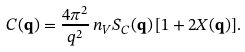<formula> <loc_0><loc_0><loc_500><loc_500>C ( { \mathbf q } ) = \frac { 4 \pi ^ { 2 } } { q ^ { 2 } } \, n _ { V } S _ { C } ( { \mathbf q } ) \, [ 1 + 2 X ( { \mathbf q } ) ] .</formula> 